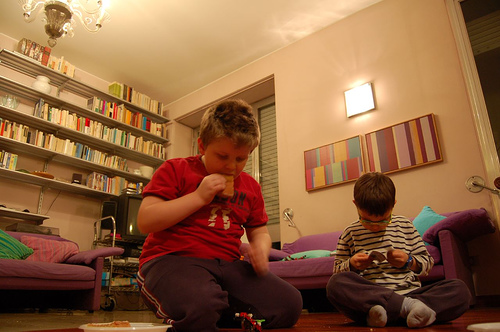<image>
Is there a big boy to the right of the small boy? Yes. From this viewpoint, the big boy is positioned to the right side relative to the small boy. 